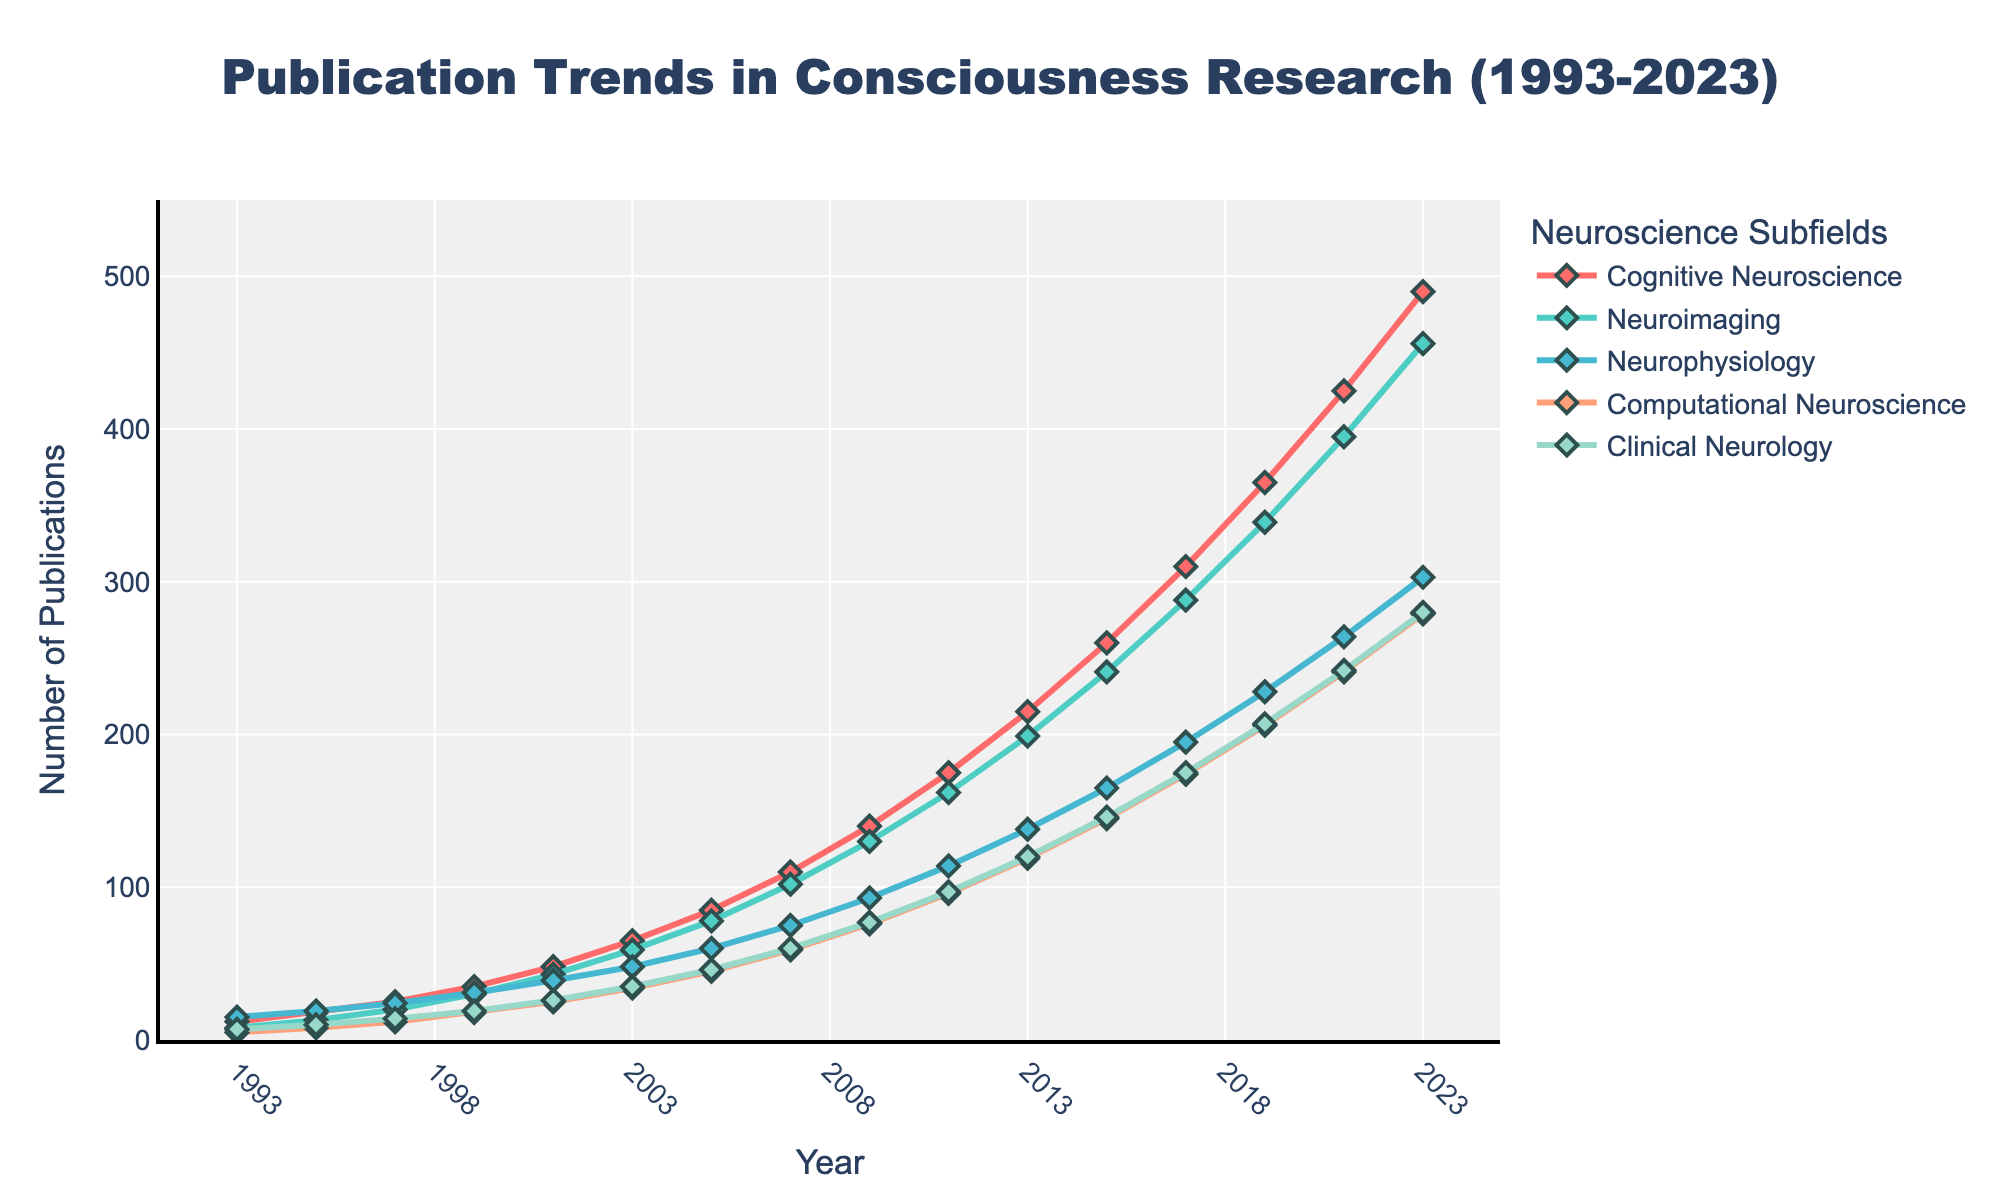What year did Cognitive Neuroscience first surpass 100 publications? To find when Cognitive Neuroscience first surpassed 100 publications, follow its line until the y-value exceeds 100. In 2007, the publications reached 110.
Answer: 2007 In 2023, what is the difference in publication numbers between Neurophysiology and Clinical Neurology? Find the publication numbers for Neurophysiology and Clinical Neurology in 2023. Neurophysiology has 303 and Clinical Neurology has 280. Subtract 280 from 303 to get 23.
Answer: 23 Which subfield has the steepest increase in publications from 1993 to 2023? Identify the subfield with the highest slope between these years. Cognitive Neuroscience goes from 12 in 1993 to 490 in 2023, which is the steepest increase.
Answer: Cognitive Neuroscience How many more publications did Neuroimaging have compared to Computational Neuroscience in 2019? Look at the 2019 values for these fields. Neuroimaging has 339, and Computational Neuroscience has 206. The difference is 339 - 206 = 133.
Answer: 133 Which subfield shows the least growth over the 30 years? Identify the subfield with the smallest overall increase. Clinical Neurology went from 7 in 1993 to 280 in 2023, which is the lowest growth compared to other subfields.
Answer: Clinical Neurology What is the average number of publications for Computational Neuroscience in 1993 and 2023? Add the publication numbers for Computational Neuroscience in 1993 and 2023. These are 5 and 279 respectively. Their sum is 284. The average is 284 / 2 = 142.
Answer: 142 Between 2011 and 2013, which subfield saw the largest absolute increase in publications? Compare the increase for each subfield between these years. Cognitive Neuroscience increased from 175 to 215, an increase of 40. Other fields had smaller increases.
Answer: Cognitive Neuroscience In what year did all the subfields cumulatively reach around 700 publications? Add the publications for each subfield across different years until reaching approximately 700. In 2001, the totals are: 48 + 43 + 39 + 25 + 26 = 181, which is not enough. In 2003, the total becomes 65 + 59 + 48 + 34 + 35 = 241, still not enough. By 2005, it’s 85 + 78 + 60 + 45 + 46 = 314. In 2007, the total is 110 + 102 + 75 + 59 + 60 = 406. In 2009, the total is 140 + 130 + 93 + 76 + 77 = 516. In 2011, adding them together gives 175 + 162 + 114 + 96 + 97 = 644, which is still below 700. Finally, in 2013, the publication numbers are 215 + 199 + 138 + 119 + 120 = 791, surpassing 700.
Answer: 2013 